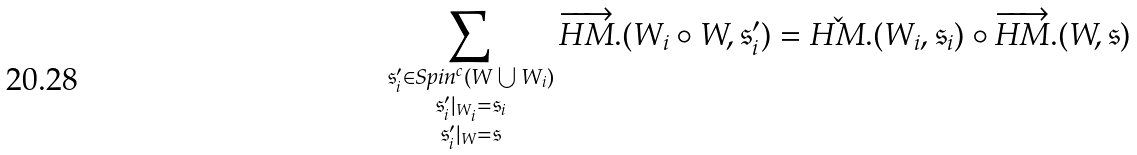<formula> <loc_0><loc_0><loc_500><loc_500>\sum _ { \substack { \mathfrak { s } _ { i } ^ { \prime } \in S p i n ^ { c } ( W \bigcup W _ { i } ) \\ \mathfrak { s } _ { i } ^ { \prime } | _ { W _ { i } } = \mathfrak { s } _ { i } \\ \mathfrak { s } _ { i } ^ { \prime } | _ { W } = \mathfrak { s } } } \overrightarrow { H M } . ( W _ { i } \circ W , \mathfrak { s } _ { i } ^ { \prime } ) = \check { H M } . ( W _ { i } , \mathfrak { s } _ { i } ) \circ \overrightarrow { H M } . ( W , \mathfrak { s } )</formula> 